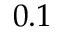Convert formula to latex. <formula><loc_0><loc_0><loc_500><loc_500>0 . 1</formula> 